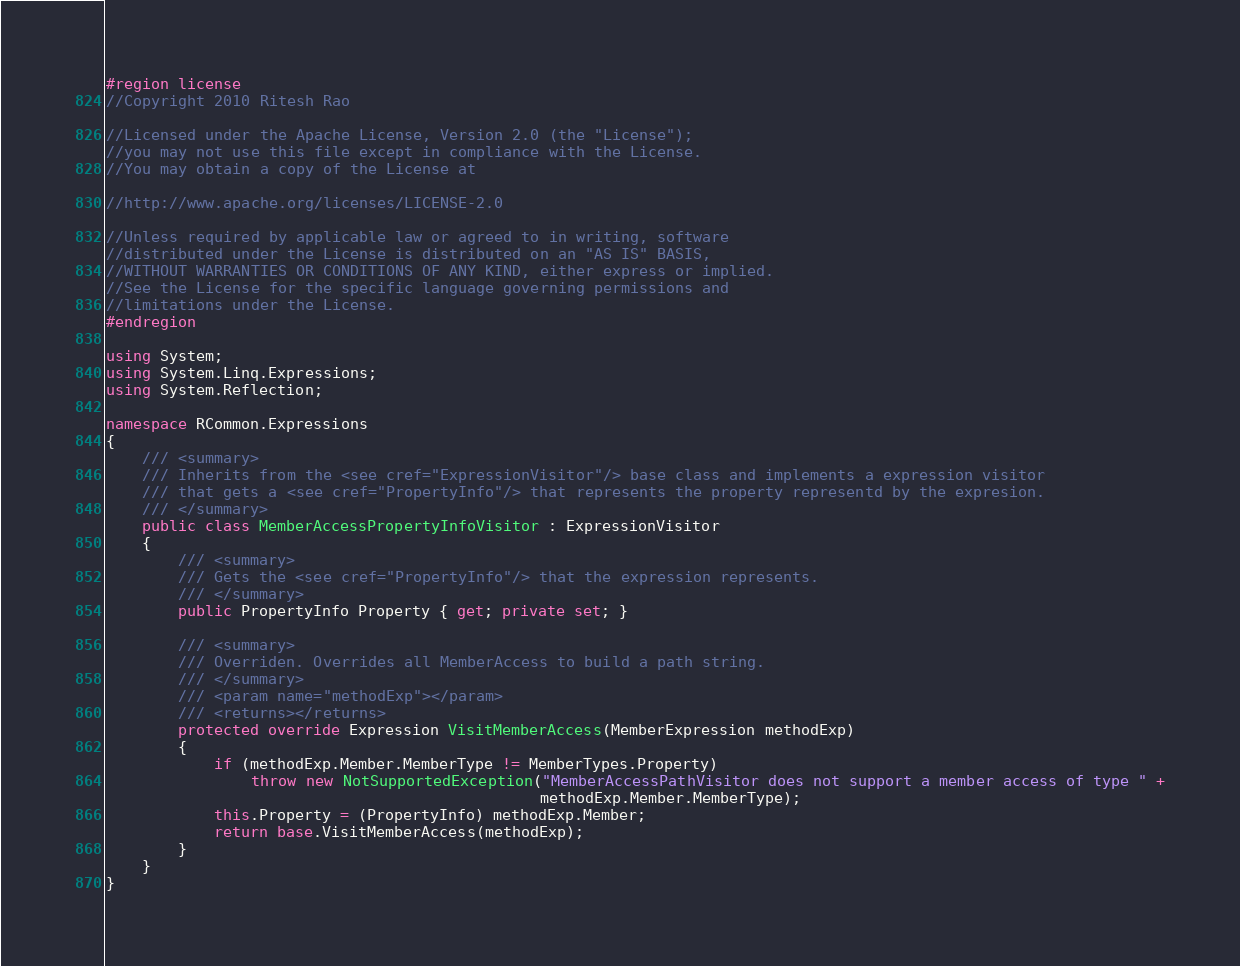Convert code to text. <code><loc_0><loc_0><loc_500><loc_500><_C#_>#region license
//Copyright 2010 Ritesh Rao 

//Licensed under the Apache License, Version 2.0 (the "License"); 
//you may not use this file except in compliance with the License. 
//You may obtain a copy of the License at 

//http://www.apache.org/licenses/LICENSE-2.0 

//Unless required by applicable law or agreed to in writing, software 
//distributed under the License is distributed on an "AS IS" BASIS, 
//WITHOUT WARRANTIES OR CONDITIONS OF ANY KIND, either express or implied. 
//See the License for the specific language governing permissions and 
//limitations under the License. 
#endregion

using System;
using System.Linq.Expressions;
using System.Reflection;

namespace RCommon.Expressions
{
    /// <summary>
    /// Inherits from the <see cref="ExpressionVisitor"/> base class and implements a expression visitor
    /// that gets a <see cref="PropertyInfo"/> that represents the property representd by the expresion.
    /// </summary>
    public class MemberAccessPropertyInfoVisitor : ExpressionVisitor
    {
        /// <summary>
        /// Gets the <see cref="PropertyInfo"/> that the expression represents.
        /// </summary>
        public PropertyInfo Property { get; private set; }

        /// <summary>
        /// Overriden. Overrides all MemberAccess to build a path string.
        /// </summary>
        /// <param name="methodExp"></param>
        /// <returns></returns>
        protected override Expression VisitMemberAccess(MemberExpression methodExp)
        {
            if (methodExp.Member.MemberType != MemberTypes.Property)
                throw new NotSupportedException("MemberAccessPathVisitor does not support a member access of type " +
                                                methodExp.Member.MemberType);
            this.Property = (PropertyInfo) methodExp.Member;
            return base.VisitMemberAccess(methodExp);
        }
    }
}</code> 